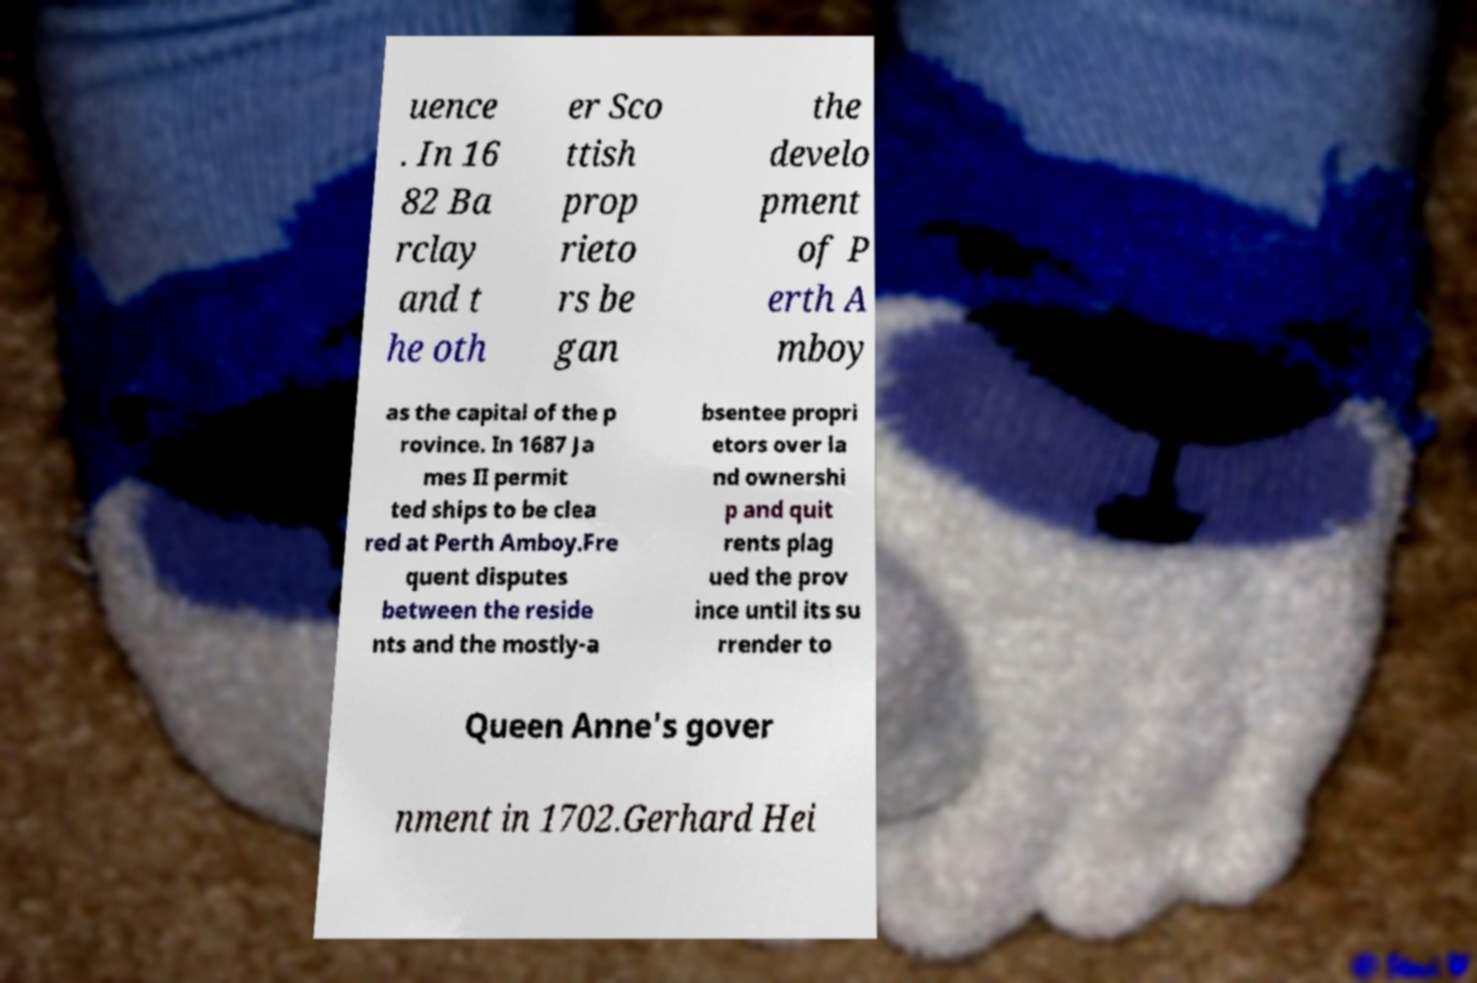Could you assist in decoding the text presented in this image and type it out clearly? uence . In 16 82 Ba rclay and t he oth er Sco ttish prop rieto rs be gan the develo pment of P erth A mboy as the capital of the p rovince. In 1687 Ja mes II permit ted ships to be clea red at Perth Amboy.Fre quent disputes between the reside nts and the mostly-a bsentee propri etors over la nd ownershi p and quit rents plag ued the prov ince until its su rrender to Queen Anne's gover nment in 1702.Gerhard Hei 